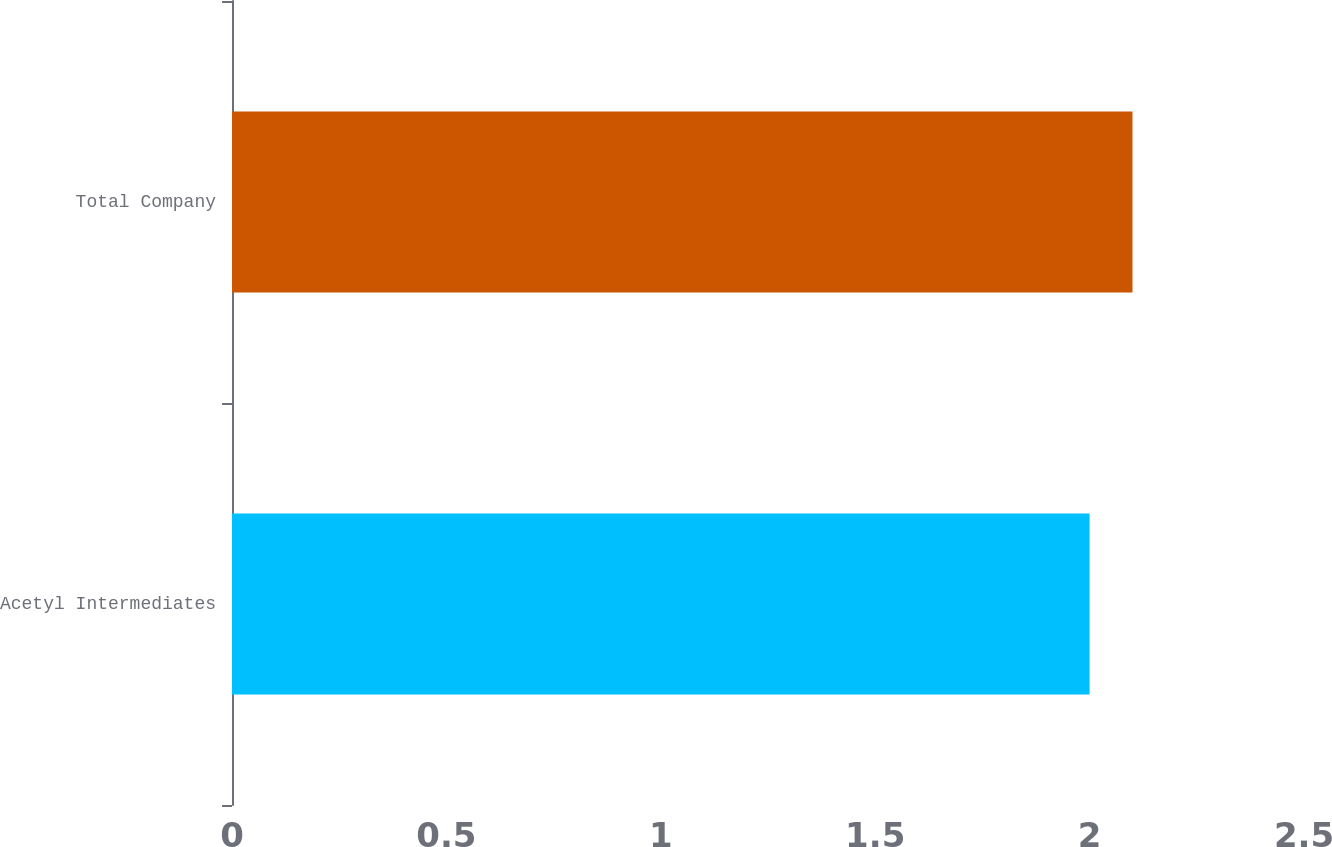Convert chart. <chart><loc_0><loc_0><loc_500><loc_500><bar_chart><fcel>Acetyl Intermediates<fcel>Total Company<nl><fcel>2<fcel>2.1<nl></chart> 